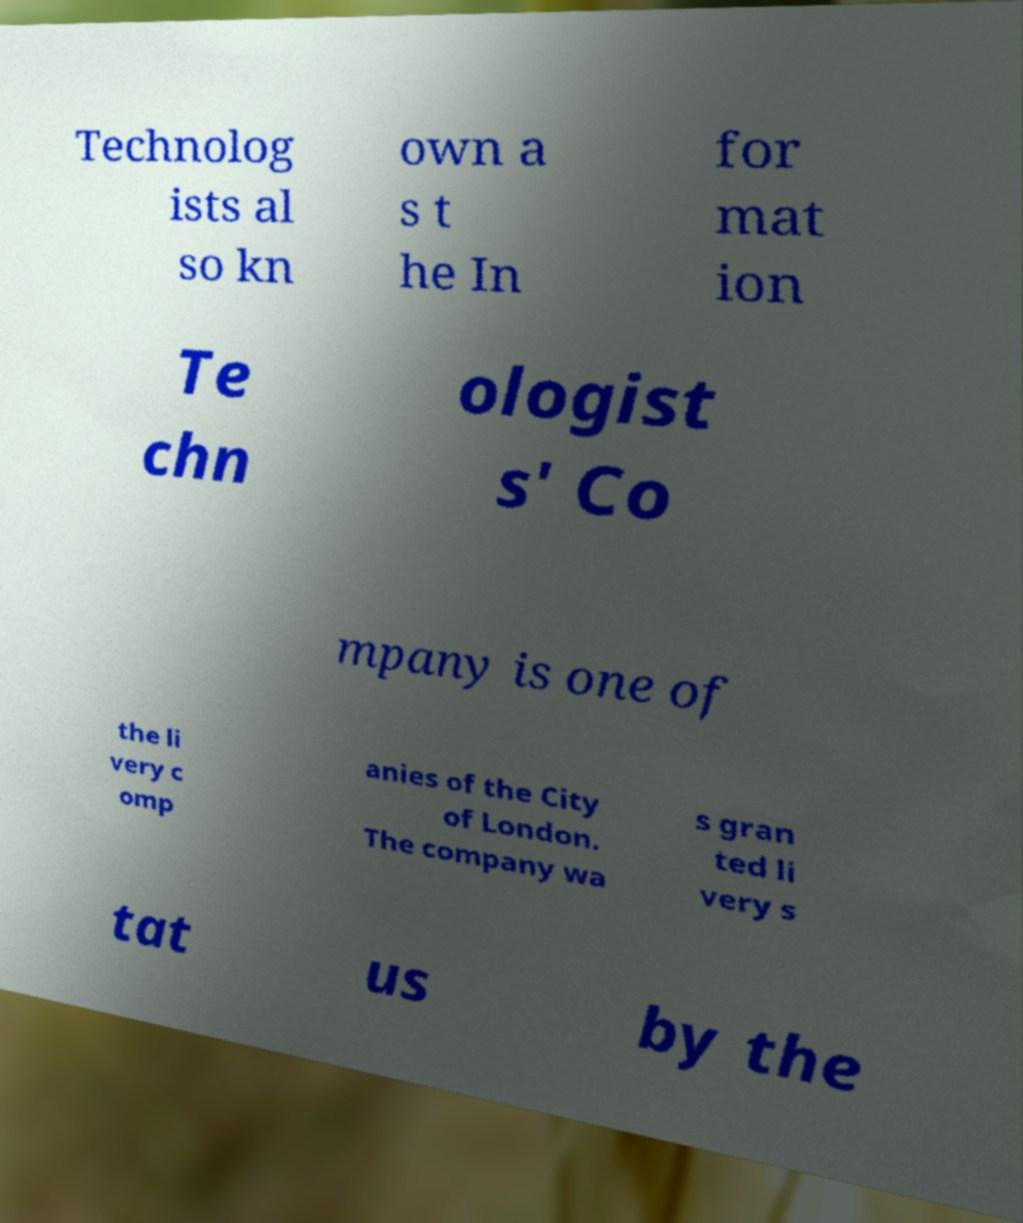Please identify and transcribe the text found in this image. Technolog ists al so kn own a s t he In for mat ion Te chn ologist s' Co mpany is one of the li very c omp anies of the City of London. The company wa s gran ted li very s tat us by the 